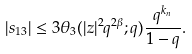Convert formula to latex. <formula><loc_0><loc_0><loc_500><loc_500>| s _ { 1 3 } | \leq 3 \theta _ { 3 } ( | z | ^ { 2 } q ^ { 2 \beta } ; q ) \frac { q ^ { k _ { n } } } { 1 - q } .</formula> 